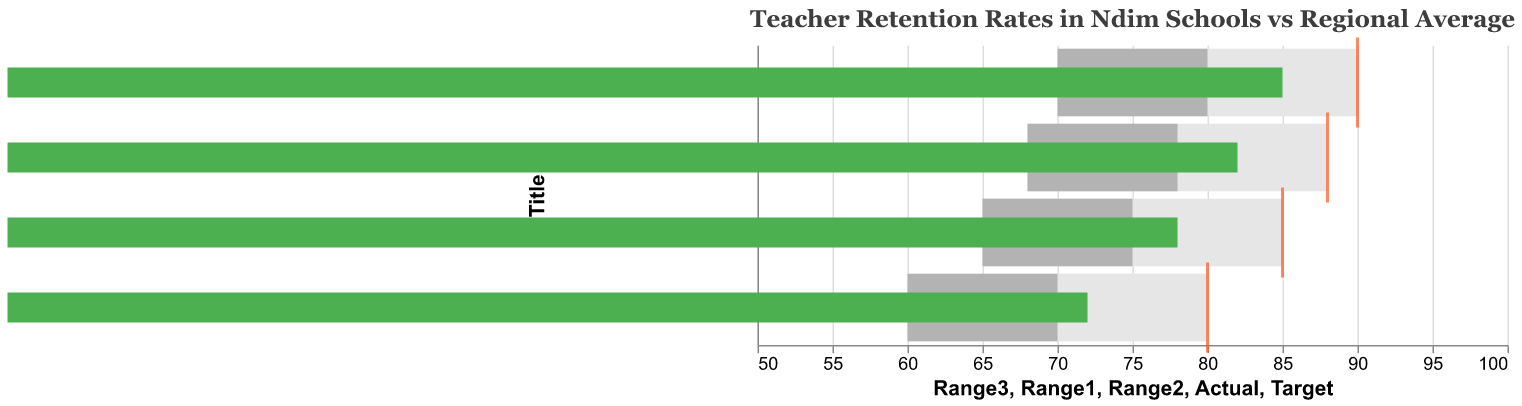What is the title of the figure? The title is usually displayed at the top of the figure, summarizing what the figure represents. In this case, the title describes the content of the chart.
Answer: Teacher Retention Rates in Ndim Schools vs Regional Average Which institution has the highest actual teacher retention rate? By looking at the green bars representing the actual retention rates, compare the lengths of the bars for different institutions.
Answer: Ndim Primary School What is the target retention rate for Ndim Secondary School? The target retention rate is represented by the orange ticks along the x-axis. Find the tick that corresponds to Ndim Secondary School.
Answer: 85 How does the actual retention rate of Ndim Technical College compare to the Regional Average? Compare the green bar lengths of Ndim Technical College and the Regional Average.
Answer: Higher What is the retention rate range considered "good" for Ndim Primary School? The ranges are color-coded in shades of gray. Identify the medium gray bar, which represents the "good" range, for Ndim Primary School.
Answer: 80-90 How much higher is the actual retention rate of Ndim Primary School compared to the Regional Average? Subtract the actual retention rate of the Regional Average from the actual retention rate of Ndim Primary School (85 - 72).
Answer: 13 Which institution has an actual retention rate below its target rate? Look at the green bars and orange ticks. Identify the institution where the green bar does not meet or exceed the orange tick mark.
Answer: Ndim Secondary School What retention rate range is considered "acceptable" for Ndim Technical College? The light gray and medium gray portions together represent the lower acceptable range. For Ndim Technical College, this is shown by the shorter bars.
Answer: 68-78 How does Ndim Secondary School's actual retention compare to its "good" range? Compare the green bar (actual retention rate) of Ndim Secondary School to the medium gray bar which denotes the "good" range.
Answer: Below Is any institution's actual retention higher than the target retention rate? Compare each institution's green bar to the corresponding orange tick mark.
Answer: No 